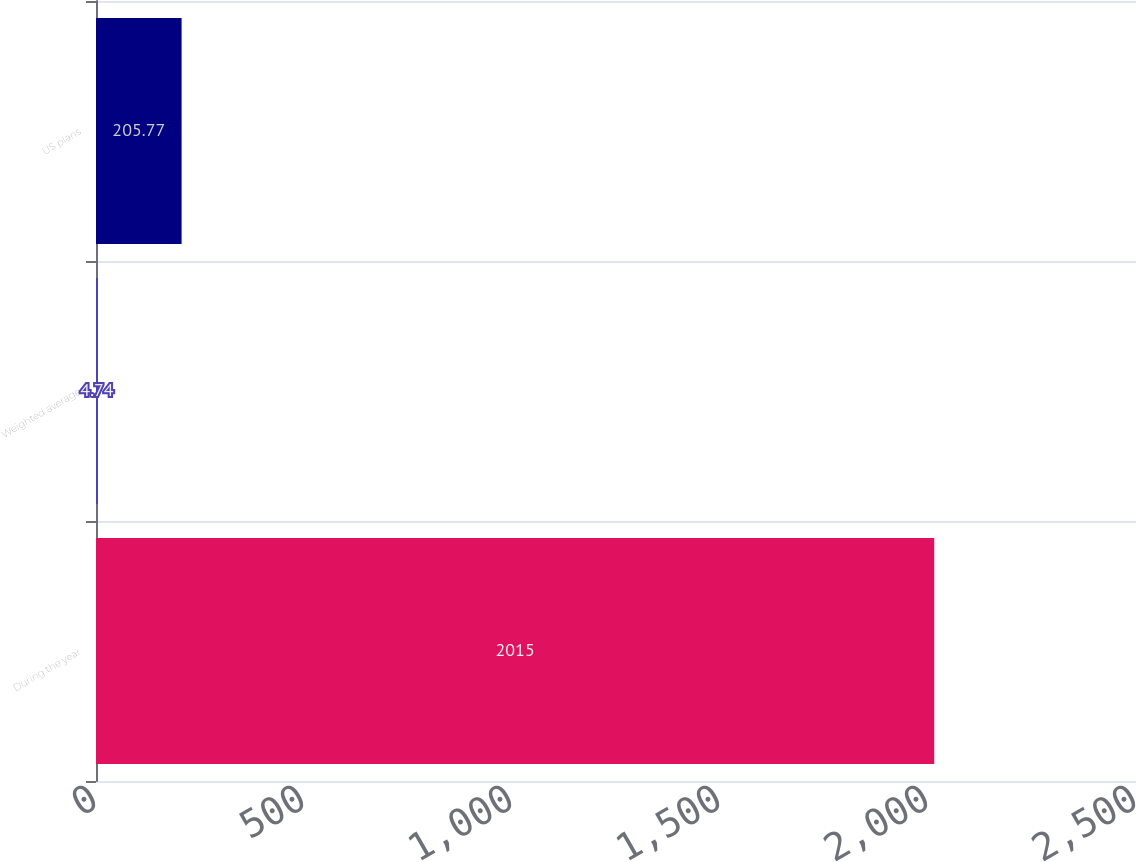<chart> <loc_0><loc_0><loc_500><loc_500><bar_chart><fcel>During the year<fcel>Weighted average<fcel>US plans<nl><fcel>2015<fcel>4.74<fcel>205.77<nl></chart> 